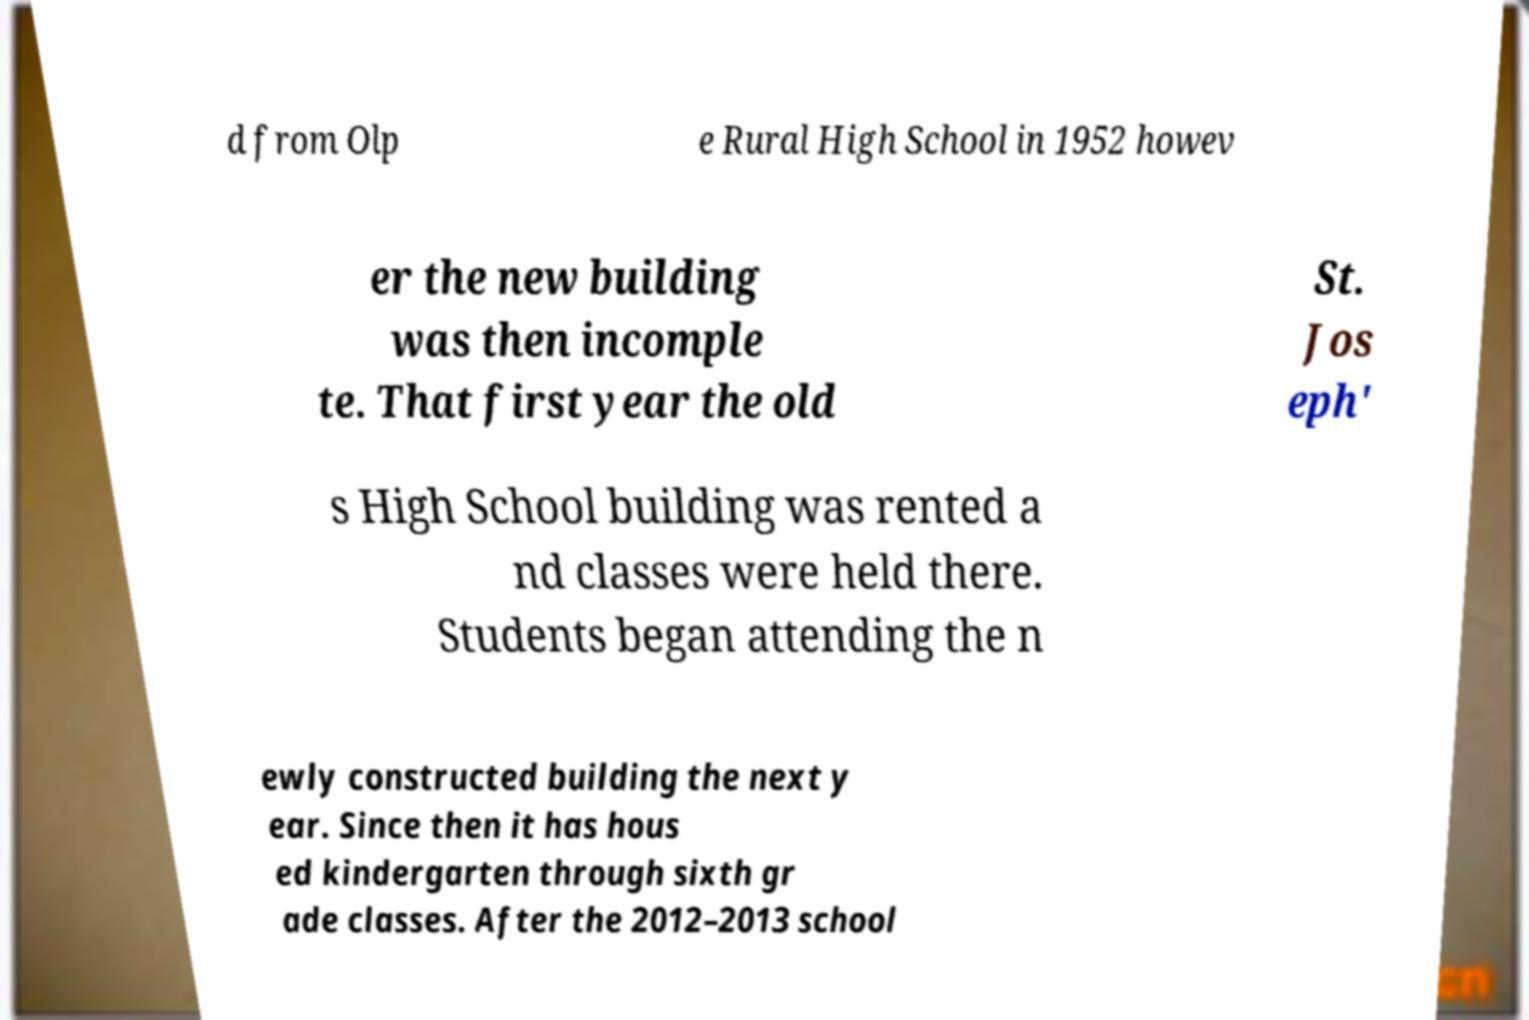There's text embedded in this image that I need extracted. Can you transcribe it verbatim? d from Olp e Rural High School in 1952 howev er the new building was then incomple te. That first year the old St. Jos eph' s High School building was rented a nd classes were held there. Students began attending the n ewly constructed building the next y ear. Since then it has hous ed kindergarten through sixth gr ade classes. After the 2012–2013 school 